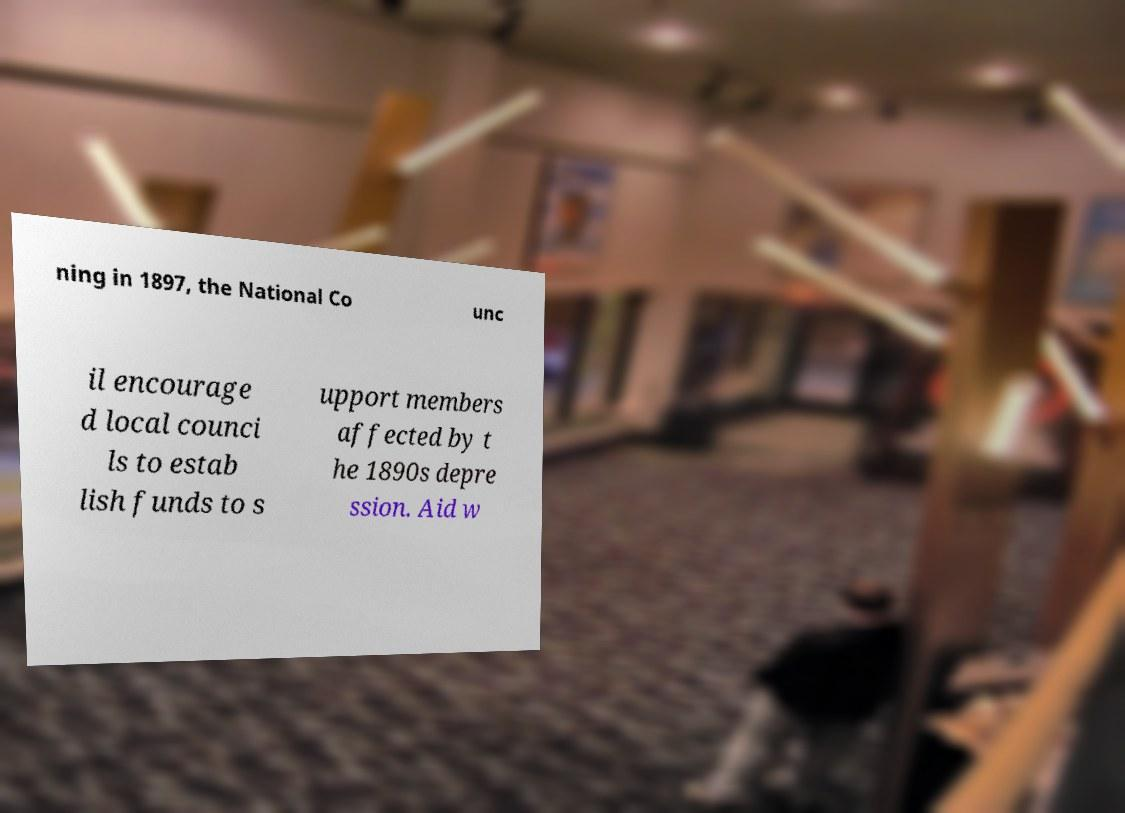For documentation purposes, I need the text within this image transcribed. Could you provide that? ning in 1897, the National Co unc il encourage d local counci ls to estab lish funds to s upport members affected by t he 1890s depre ssion. Aid w 